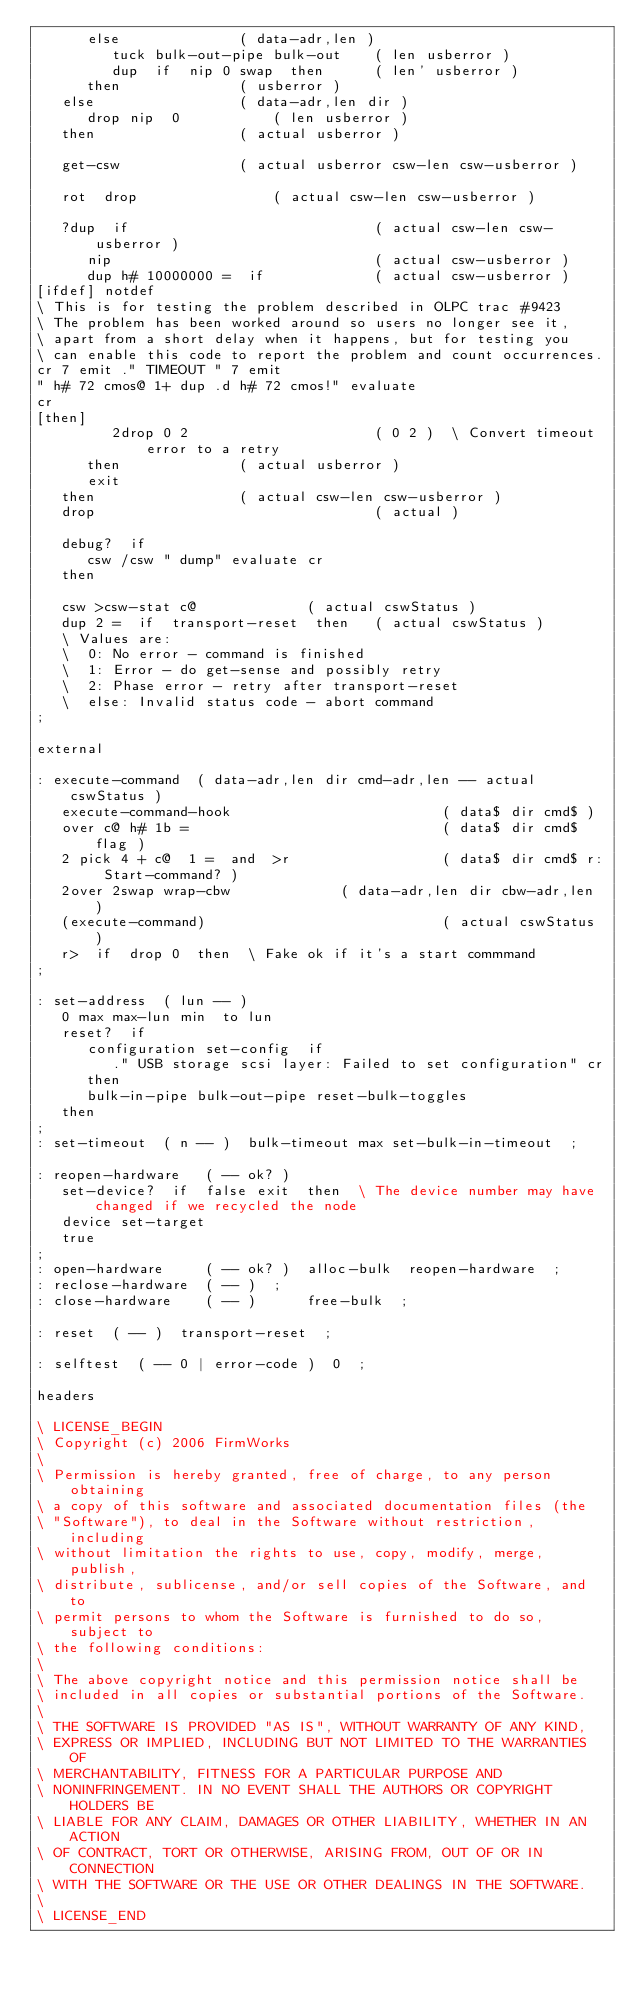Convert code to text. <code><loc_0><loc_0><loc_500><loc_500><_Forth_>      else				( data-adr,len )
         tuck bulk-out-pipe bulk-out    ( len usberror )
         dup  if  nip 0 swap  then      ( len' usberror )
      then				( usberror )
   else					( data-adr,len dir )
      drop nip  0			( len usberror )
   then					( actual usberror )

   get-csw				( actual usberror csw-len csw-usberror )

   rot  drop				( actual csw-len csw-usberror )

   ?dup  if                             ( actual csw-len csw-usberror )
      nip                               ( actual csw-usberror )
      dup h# 10000000 =  if             ( actual csw-usberror )
[ifdef] notdef
\ This is for testing the problem described in OLPC trac #9423
\ The problem has been worked around so users no longer see it,
\ apart from a short delay when it happens, but for testing you
\ can enable this code to report the problem and count occurrences.
cr 7 emit ." TIMEOUT " 7 emit
" h# 72 cmos@ 1+ dup .d h# 72 cmos!" evaluate
cr
[then]
         2drop 0 2                      ( 0 2 )  \ Convert timeout error to a retry
      then				( actual usberror )
      exit
   then					( actual csw-len csw-usberror )
   drop                                 ( actual )

   debug?  if
      csw /csw " dump" evaluate cr
   then

   csw >csw-stat c@		        ( actual cswStatus )
   dup 2 =  if  transport-reset  then   ( actual cswStatus )
   \ Values are:
   \  0: No error - command is finished
   \  1: Error - do get-sense and possibly retry
   \  2: Phase error - retry after transport-reset
   \  else: Invalid status code - abort command
;

external

: execute-command  ( data-adr,len dir cmd-adr,len -- actual cswStatus )
   execute-command-hook                         ( data$ dir cmd$ )
   over c@ h# 1b =                              ( data$ dir cmd$ flag )
   2 pick 4 + c@  1 =  and  >r	                ( data$ dir cmd$ r: Start-command? )
   2over 2swap wrap-cbw				( data-adr,len dir cbw-adr,len )
   (execute-command)                            ( actual cswStatus )
   r>  if  drop 0  then  \ Fake ok if it's a start commmand
;

: set-address  ( lun -- )
   0 max max-lun min  to lun
   reset?  if
      configuration set-config  if
         ." USB storage scsi layer: Failed to set configuration" cr
      then
      bulk-in-pipe bulk-out-pipe reset-bulk-toggles
   then
;
: set-timeout  ( n -- )  bulk-timeout max set-bulk-in-timeout  ;

: reopen-hardware   ( -- ok? )
   set-device?  if  false exit  then  \ The device number may have changed if we recycled the node
   device set-target
   true
;
: open-hardware     ( -- ok? )  alloc-bulk  reopen-hardware  ;
: reclose-hardware  ( -- )	;
: close-hardware    ( -- )      free-bulk  ;

: reset  ( -- )  transport-reset  ;

: selftest  ( -- 0 | error-code )  0  ;

headers

\ LICENSE_BEGIN
\ Copyright (c) 2006 FirmWorks
\ 
\ Permission is hereby granted, free of charge, to any person obtaining
\ a copy of this software and associated documentation files (the
\ "Software"), to deal in the Software without restriction, including
\ without limitation the rights to use, copy, modify, merge, publish,
\ distribute, sublicense, and/or sell copies of the Software, and to
\ permit persons to whom the Software is furnished to do so, subject to
\ the following conditions:
\ 
\ The above copyright notice and this permission notice shall be
\ included in all copies or substantial portions of the Software.
\ 
\ THE SOFTWARE IS PROVIDED "AS IS", WITHOUT WARRANTY OF ANY KIND,
\ EXPRESS OR IMPLIED, INCLUDING BUT NOT LIMITED TO THE WARRANTIES OF
\ MERCHANTABILITY, FITNESS FOR A PARTICULAR PURPOSE AND
\ NONINFRINGEMENT. IN NO EVENT SHALL THE AUTHORS OR COPYRIGHT HOLDERS BE
\ LIABLE FOR ANY CLAIM, DAMAGES OR OTHER LIABILITY, WHETHER IN AN ACTION
\ OF CONTRACT, TORT OR OTHERWISE, ARISING FROM, OUT OF OR IN CONNECTION
\ WITH THE SOFTWARE OR THE USE OR OTHER DEALINGS IN THE SOFTWARE.
\
\ LICENSE_END
</code> 